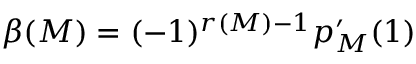Convert formula to latex. <formula><loc_0><loc_0><loc_500><loc_500>\beta ( M ) = ( - 1 ) ^ { r ( M ) - 1 } p _ { M } ^ { \prime } ( 1 )</formula> 